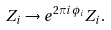Convert formula to latex. <formula><loc_0><loc_0><loc_500><loc_500>Z _ { i } \to e ^ { 2 \pi i \phi _ { i } } Z _ { i } .</formula> 